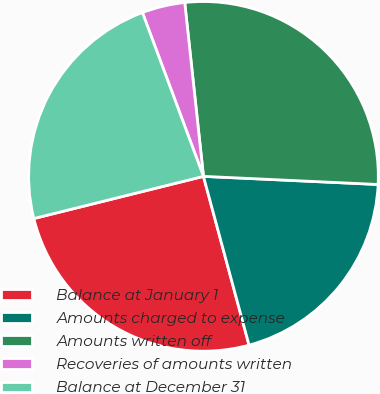Convert chart to OTSL. <chart><loc_0><loc_0><loc_500><loc_500><pie_chart><fcel>Balance at January 1<fcel>Amounts charged to expense<fcel>Amounts written off<fcel>Recoveries of amounts written<fcel>Balance at December 31<nl><fcel>25.32%<fcel>20.06%<fcel>27.45%<fcel>3.97%<fcel>23.2%<nl></chart> 